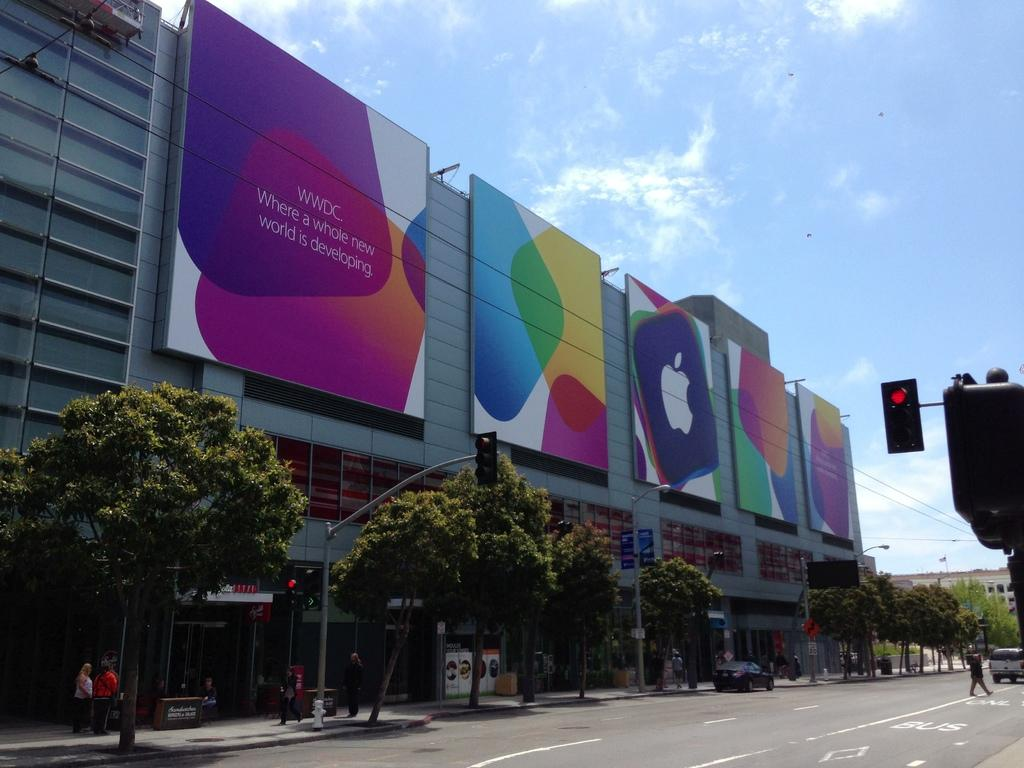Provide a one-sentence caption for the provided image. The WWDC is advertised on a multi-piece billboard. 